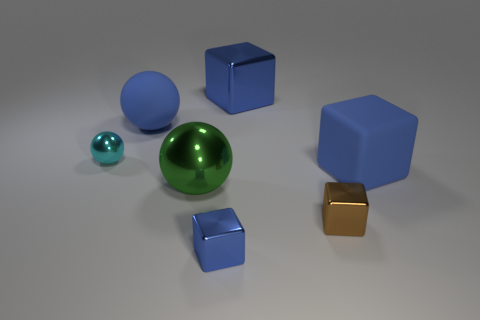How many metallic spheres have the same color as the large matte ball?
Offer a very short reply. 0. How many tiny things are blue rubber objects or blue things?
Your answer should be very brief. 1. What is the size of the rubber cube that is the same color as the big metallic block?
Give a very brief answer. Large. Is there a green ball that has the same material as the large green object?
Your answer should be compact. No. What material is the large blue block that is behind the tiny cyan metallic thing?
Provide a succinct answer. Metal. Does the tiny metal object behind the big green sphere have the same color as the big matte object right of the big green ball?
Your response must be concise. No. There is a metallic sphere that is the same size as the brown cube; what is its color?
Give a very brief answer. Cyan. What number of other things are there of the same shape as the tiny blue metallic thing?
Keep it short and to the point. 3. What is the size of the green metal thing in front of the tiny metallic ball?
Offer a very short reply. Large. There is a cube that is right of the brown metal block; how many tiny shiny objects are behind it?
Offer a very short reply. 1. 